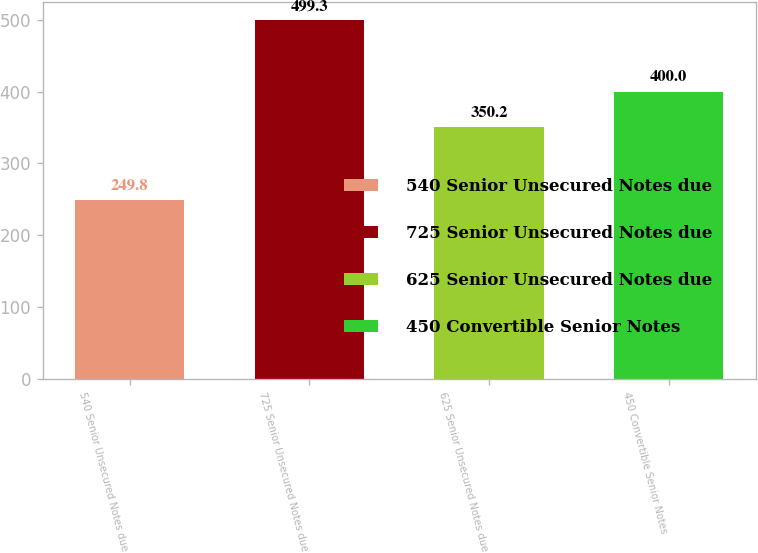Convert chart. <chart><loc_0><loc_0><loc_500><loc_500><bar_chart><fcel>540 Senior Unsecured Notes due<fcel>725 Senior Unsecured Notes due<fcel>625 Senior Unsecured Notes due<fcel>450 Convertible Senior Notes<nl><fcel>249.8<fcel>499.3<fcel>350.2<fcel>400<nl></chart> 